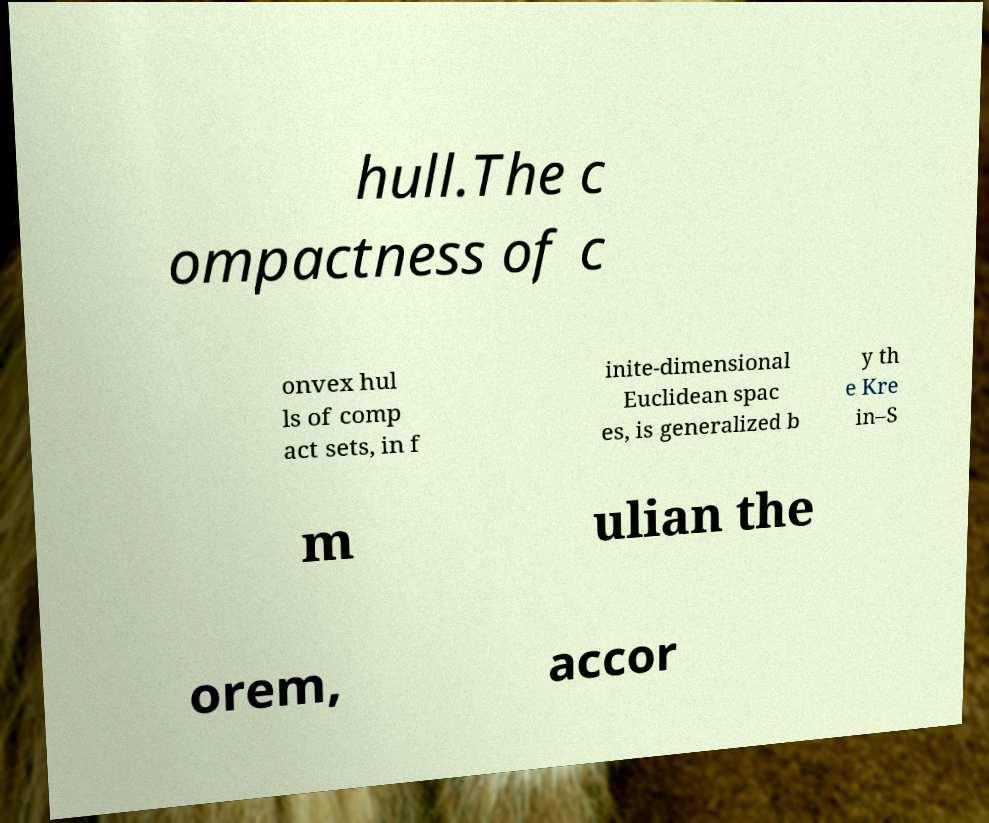For documentation purposes, I need the text within this image transcribed. Could you provide that? hull.The c ompactness of c onvex hul ls of comp act sets, in f inite-dimensional Euclidean spac es, is generalized b y th e Kre in–S m ulian the orem, accor 